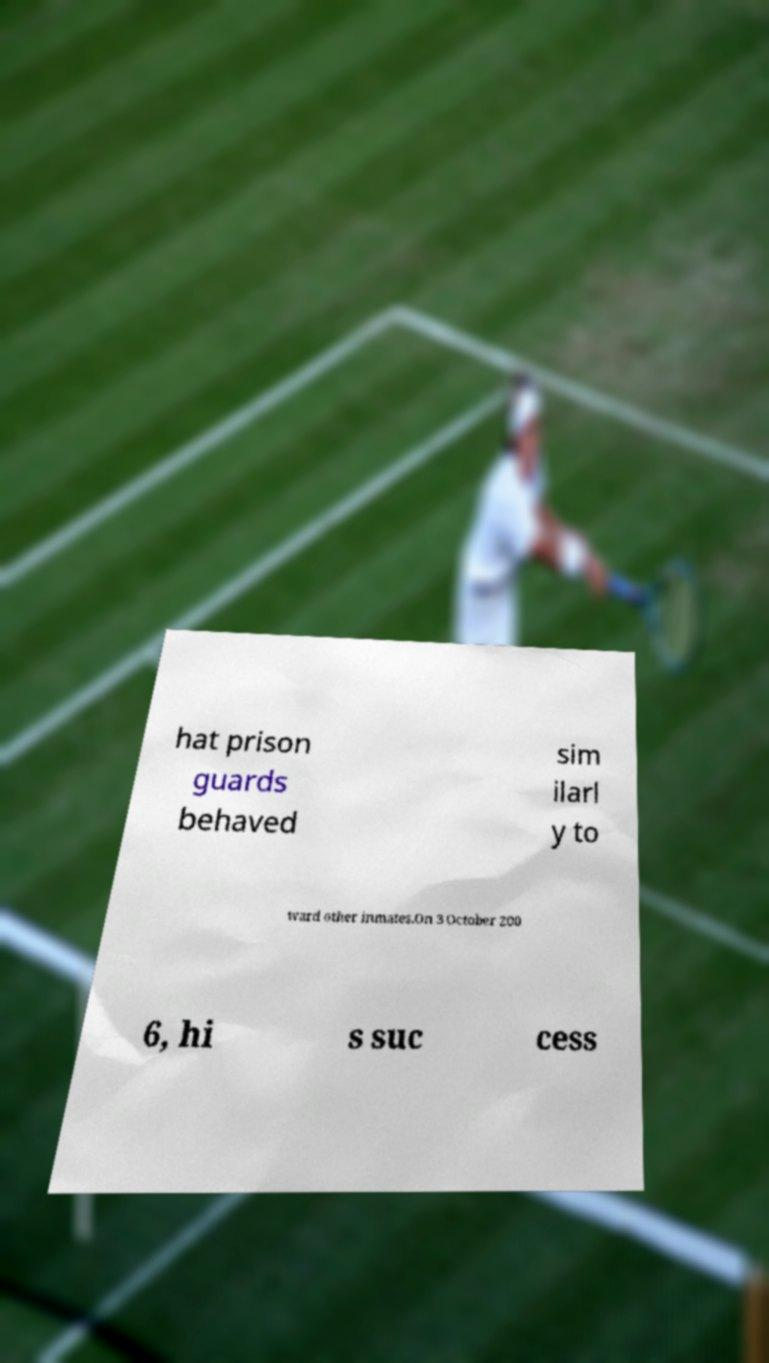What messages or text are displayed in this image? I need them in a readable, typed format. hat prison guards behaved sim ilarl y to ward other inmates.On 3 October 200 6, hi s suc cess 